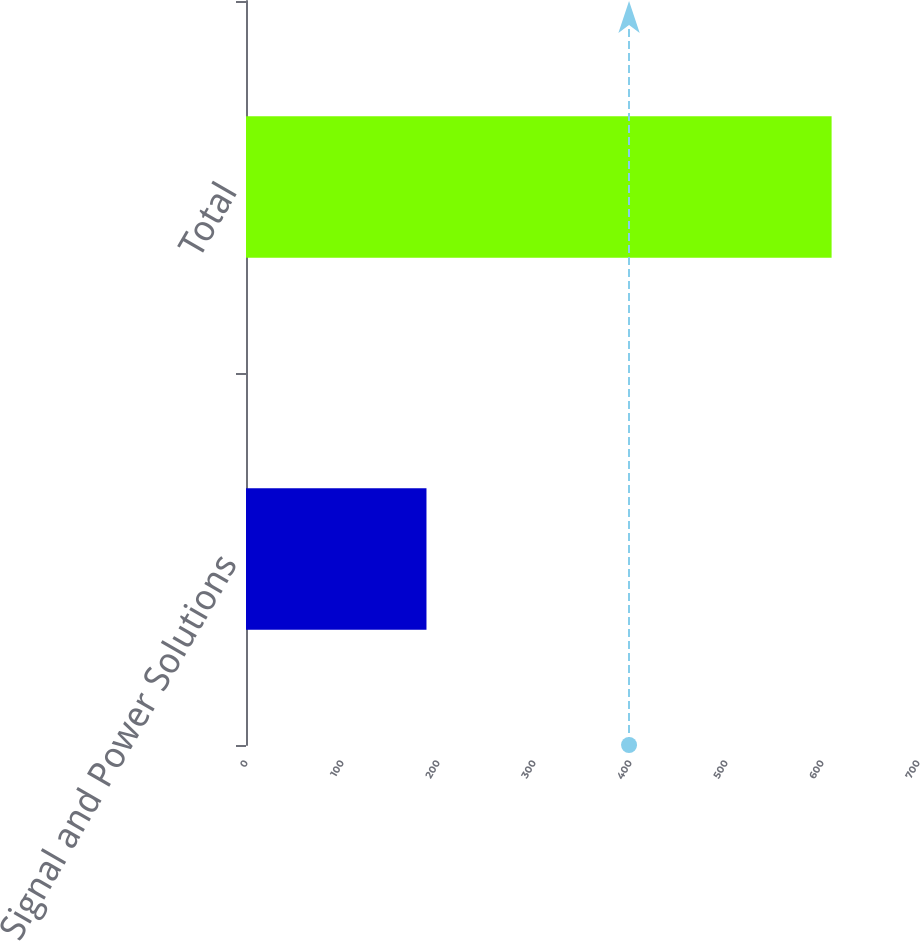<chart> <loc_0><loc_0><loc_500><loc_500><bar_chart><fcel>Signal and Power Solutions<fcel>Total<nl><fcel>188<fcel>610<nl></chart> 